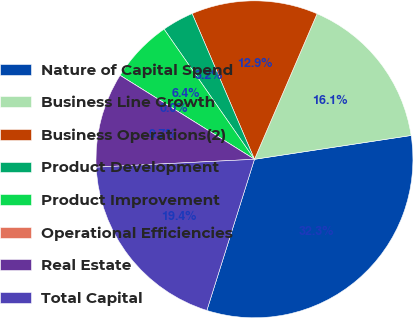Convert chart. <chart><loc_0><loc_0><loc_500><loc_500><pie_chart><fcel>Nature of Capital Spend<fcel>Business Line Growth<fcel>Business Operations(2)<fcel>Product Development<fcel>Product Improvement<fcel>Operational Efficiencies<fcel>Real Estate<fcel>Total Capital<nl><fcel>32.26%<fcel>16.13%<fcel>12.9%<fcel>3.23%<fcel>6.45%<fcel>0.0%<fcel>9.68%<fcel>19.35%<nl></chart> 